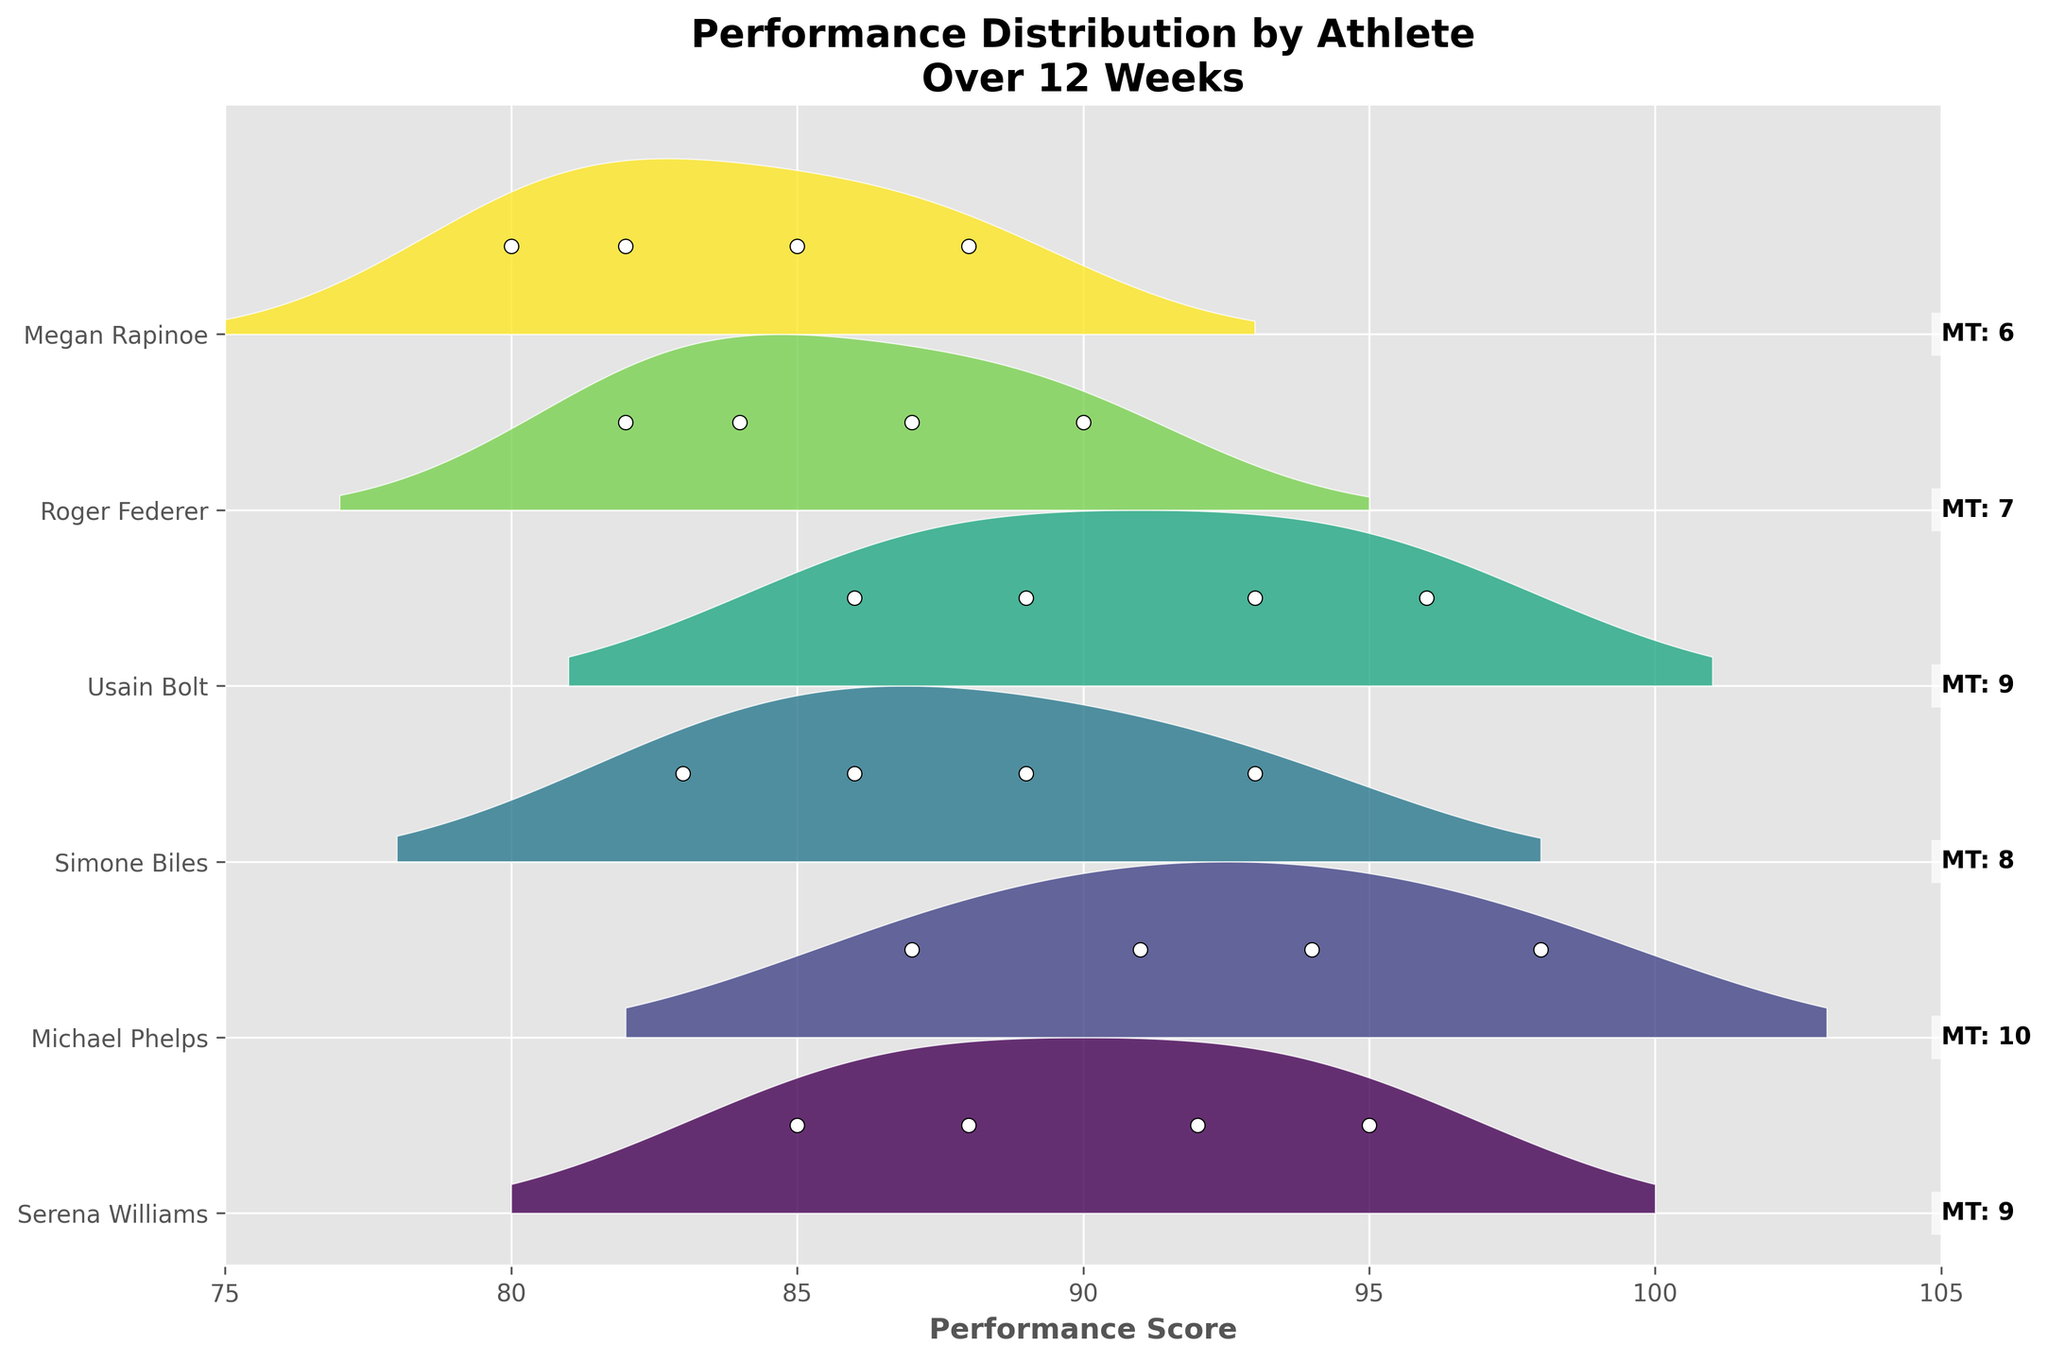what is the title of the figure? The title is designed to give a concise summary of what the plot represents. It is typically placed at the top of the figure.
Answer: Performance Distribution by Athlete Over 12 Weeks Which athlete has the highest mental toughness rating? The mental toughness rating is displayed in a text box on the right side of the plot for each athlete. The highest mental toughness value is 10.
Answer: Michael Phelps How does the performance distribution of Serena Williams compare to that of Megan Rapinoe? Examining the distribution shapes, Serena Williams' performance scores are clustered between 85 and 95, showing a higher peak, whereas Megan Rapinoe's scores range between 80 and 88, indicating a narrower distribution. The peaks and ranges directly show the spread and central tendency of the scores.
Answer: Serena Williams has higher and more concentrated performance scores compared to Megan Rapinoe whose scores are lower and less varied What is the range of the x-axis in the plot? The x-axis represents performance scores. The range can be determined by looking at the leftmost and rightmost values displayed on the axis.
Answer: 75 to 105 Which athlete shows the largest performance increase over 12 weeks? By looking at the plot indicators (white dots) corresponding to week 1 and week 12 for each athlete and measuring the difference, Michael Phelps stands out with a performance increase from 87 to 98.
Answer: Michael Phelps What is the average starting performance score across all athletes? To find this, note the starting scores for each athlete (week 1): Serena Williams (85), Michael Phelps (87), Simone Biles (83), Usain Bolt (86), Roger Federer (82), Megan Rapinoe (80). The average is calculated as (85 + 87 + 83 + 86 + 82 + 80) / 6 = 503 / 6.
Answer: 83.83 How many different colors are used in the plot? Each athlete is represented by a unique color which corresponds to their distribution area in the ridgeline plot. Counting the number of unique color areas gives the answer.
Answer: 6 colors Which athletes have their performance scores ending in week 12 above 95? By checking the performance scores for week 12 (right-most white dots for each athlete): Serena Williams (95), Michael Phelps (98), Simone Biles (93), Usain Bolt (96), Roger Federer (90), Megan Rapinoe (88). Only Michael Phelps and Usain Bolt have scores above 95.
Answer: Michael Phelps and Usain Bolt What is the mental toughness rating for Simone Biles? The mental toughness rating is displayed next to each athlete's name on the right side of the plot. Locate Simone Biles and read off the value.
Answer: 8 